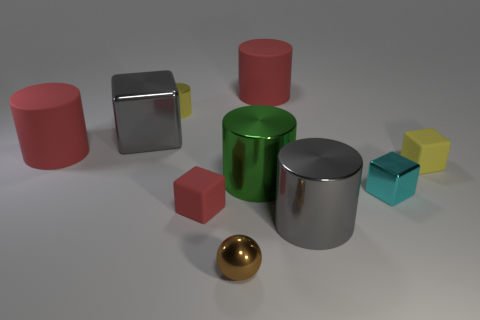Subtract all brown balls. How many red cylinders are left? 2 Subtract all green cylinders. How many cylinders are left? 4 Subtract all yellow shiny cylinders. How many cylinders are left? 4 Subtract all blue blocks. Subtract all cyan cylinders. How many blocks are left? 4 Subtract all spheres. How many objects are left? 9 Subtract 1 yellow blocks. How many objects are left? 9 Subtract all big blue metallic cylinders. Subtract all large green metallic cylinders. How many objects are left? 9 Add 1 large things. How many large things are left? 6 Add 8 large green balls. How many large green balls exist? 8 